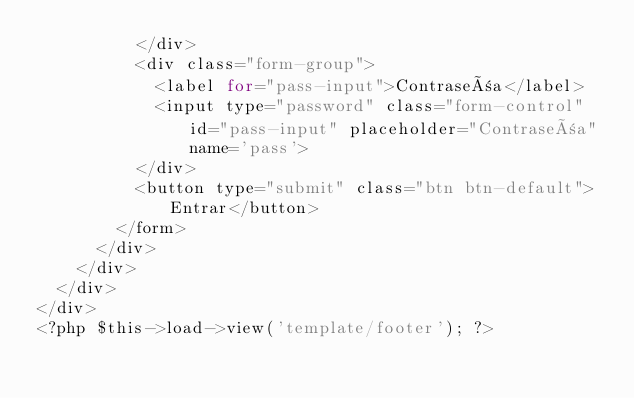<code> <loc_0><loc_0><loc_500><loc_500><_PHP_>					</div>
					<div class="form-group">
						<label for="pass-input">Contraseña</label>
						<input type="password" class="form-control" id="pass-input" placeholder="Contraseña" name='pass'>
					</div>
					<button type="submit" class="btn btn-default">Entrar</button>
				</form>
			</div>
		</div>
	</div>
</div>
<?php $this->load->view('template/footer'); ?></code> 